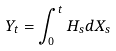Convert formula to latex. <formula><loc_0><loc_0><loc_500><loc_500>Y _ { t } = \int _ { 0 } ^ { t } H _ { s } d X _ { s }</formula> 